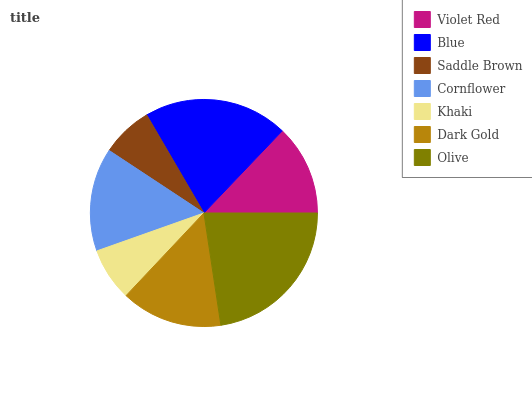Is Saddle Brown the minimum?
Answer yes or no. Yes. Is Olive the maximum?
Answer yes or no. Yes. Is Blue the minimum?
Answer yes or no. No. Is Blue the maximum?
Answer yes or no. No. Is Blue greater than Violet Red?
Answer yes or no. Yes. Is Violet Red less than Blue?
Answer yes or no. Yes. Is Violet Red greater than Blue?
Answer yes or no. No. Is Blue less than Violet Red?
Answer yes or no. No. Is Dark Gold the high median?
Answer yes or no. Yes. Is Dark Gold the low median?
Answer yes or no. Yes. Is Violet Red the high median?
Answer yes or no. No. Is Khaki the low median?
Answer yes or no. No. 